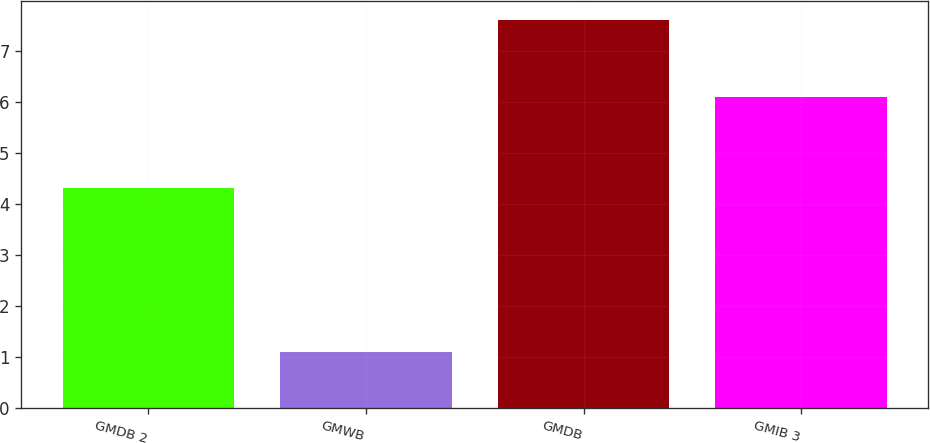<chart> <loc_0><loc_0><loc_500><loc_500><bar_chart><fcel>GMDB 2<fcel>GMWB<fcel>GMDB<fcel>GMIB 3<nl><fcel>4.3<fcel>1.1<fcel>7.6<fcel>6.1<nl></chart> 